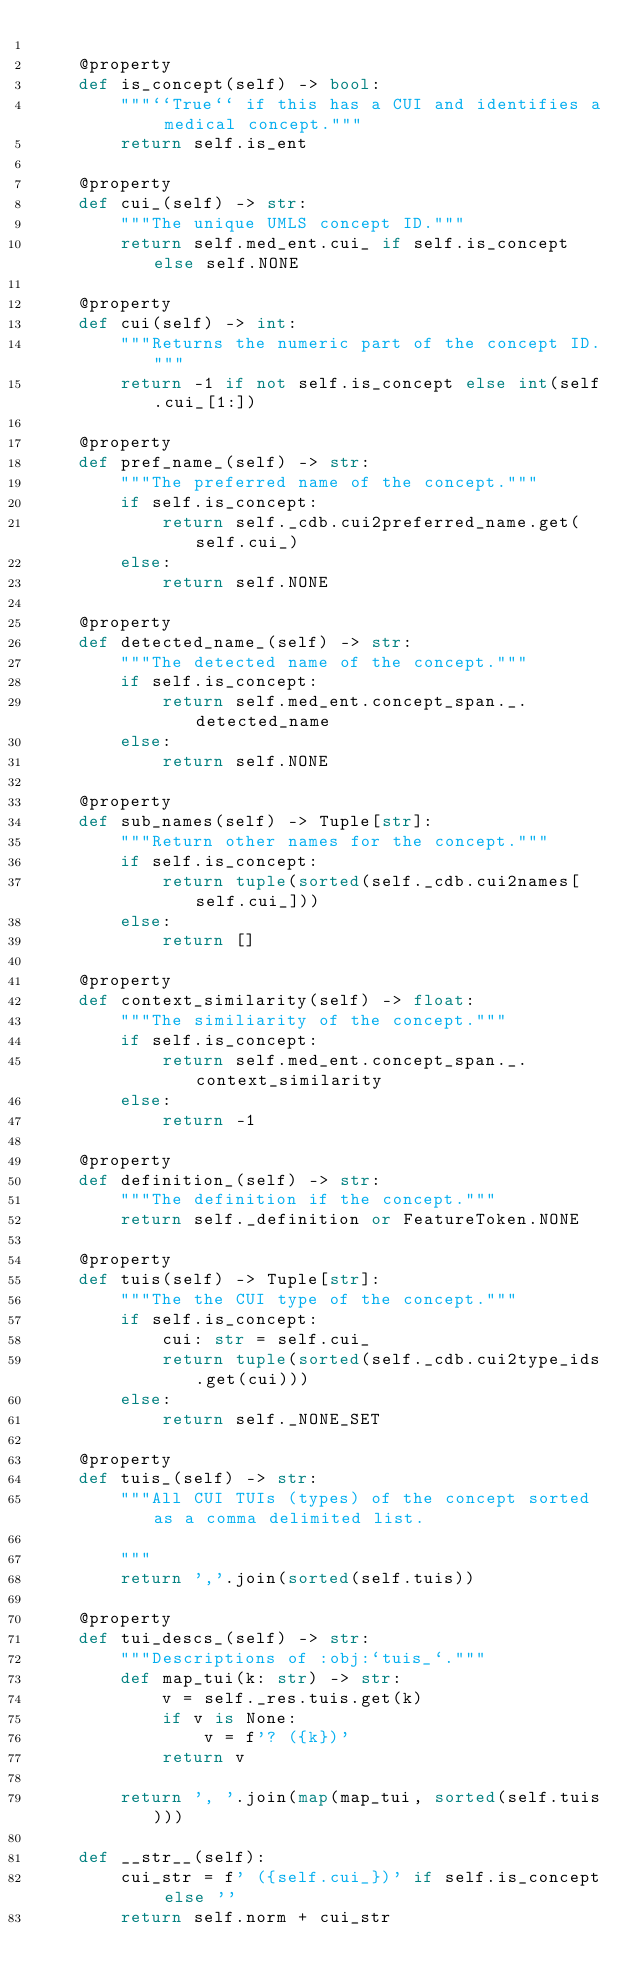Convert code to text. <code><loc_0><loc_0><loc_500><loc_500><_Python_>
    @property
    def is_concept(self) -> bool:
        """``True`` if this has a CUI and identifies a medical concept."""
        return self.is_ent

    @property
    def cui_(self) -> str:
        """The unique UMLS concept ID."""
        return self.med_ent.cui_ if self.is_concept else self.NONE

    @property
    def cui(self) -> int:
        """Returns the numeric part of the concept ID."""
        return -1 if not self.is_concept else int(self.cui_[1:])

    @property
    def pref_name_(self) -> str:
        """The preferred name of the concept."""
        if self.is_concept:
            return self._cdb.cui2preferred_name.get(self.cui_)
        else:
            return self.NONE

    @property
    def detected_name_(self) -> str:
        """The detected name of the concept."""
        if self.is_concept:
            return self.med_ent.concept_span._.detected_name
        else:
            return self.NONE

    @property
    def sub_names(self) -> Tuple[str]:
        """Return other names for the concept."""
        if self.is_concept:
            return tuple(sorted(self._cdb.cui2names[self.cui_]))
        else:
            return []

    @property
    def context_similarity(self) -> float:
        """The similiarity of the concept."""
        if self.is_concept:
            return self.med_ent.concept_span._.context_similarity
        else:
            return -1

    @property
    def definition_(self) -> str:
        """The definition if the concept."""
        return self._definition or FeatureToken.NONE

    @property
    def tuis(self) -> Tuple[str]:
        """The the CUI type of the concept."""
        if self.is_concept:
            cui: str = self.cui_
            return tuple(sorted(self._cdb.cui2type_ids.get(cui)))
        else:
            return self._NONE_SET

    @property
    def tuis_(self) -> str:
        """All CUI TUIs (types) of the concept sorted as a comma delimited list.

        """
        return ','.join(sorted(self.tuis))

    @property
    def tui_descs_(self) -> str:
        """Descriptions of :obj:`tuis_`."""
        def map_tui(k: str) -> str:
            v = self._res.tuis.get(k)
            if v is None:
                v = f'? ({k})'
            return v

        return ', '.join(map(map_tui, sorted(self.tuis)))

    def __str__(self):
        cui_str = f' ({self.cui_})' if self.is_concept else ''
        return self.norm + cui_str
</code> 